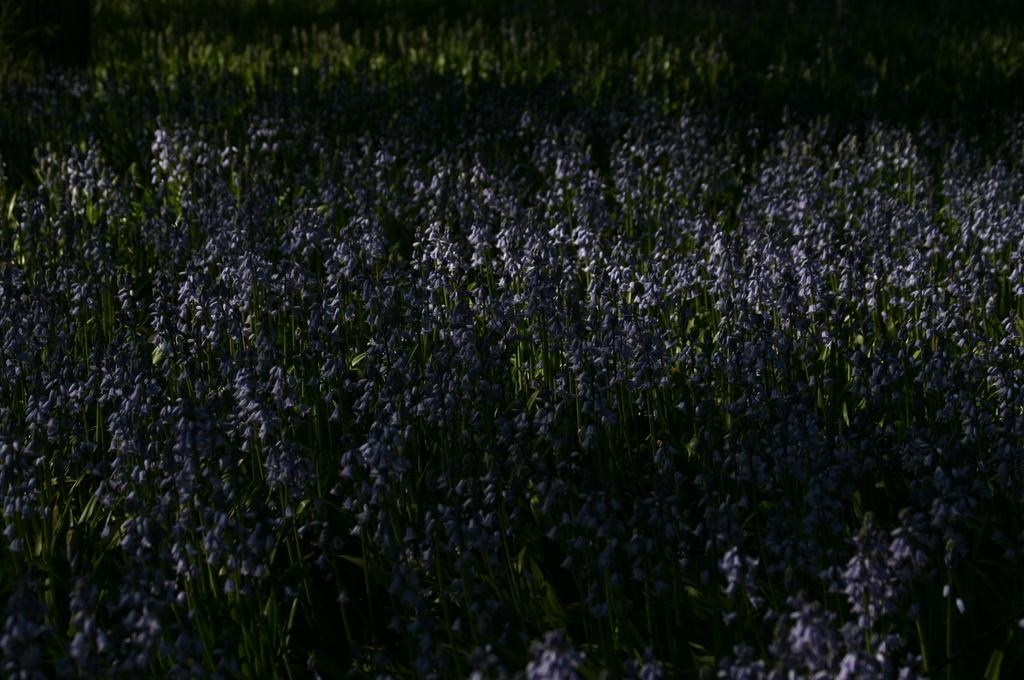What type of living organisms can be seen in the image? Plants and flowers are visible in the image. What color are the flowers in the image? The flowers in the image are purple. What type of war is being discussed in the image? There is no discussion of war in the image; it features plants and flowers. What type of writing can be seen on the flowers in the image? There is no writing present on the flowers in the image. 